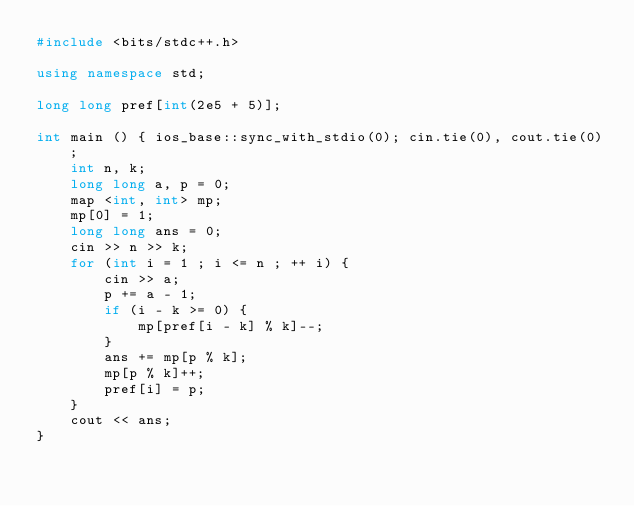<code> <loc_0><loc_0><loc_500><loc_500><_C++_>#include <bits/stdc++.h>

using namespace std;

long long pref[int(2e5 + 5)];

int main () { ios_base::sync_with_stdio(0); cin.tie(0), cout.tie(0);
	int n, k;
	long long a, p = 0;
	map <int, int> mp;
	mp[0] = 1;
	long long ans = 0;
	cin >> n >> k;
	for (int i = 1 ; i <= n ; ++ i) {
		cin >> a;
		p += a - 1;
		if (i - k >= 0) {
			mp[pref[i - k] % k]--;
		}
		ans += mp[p % k];
		mp[p % k]++;
		pref[i] = p;
	}
	cout << ans;
}
</code> 